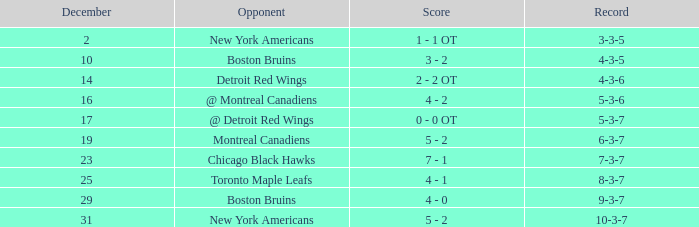Which December has a Record of 4-3-6? 14.0. 